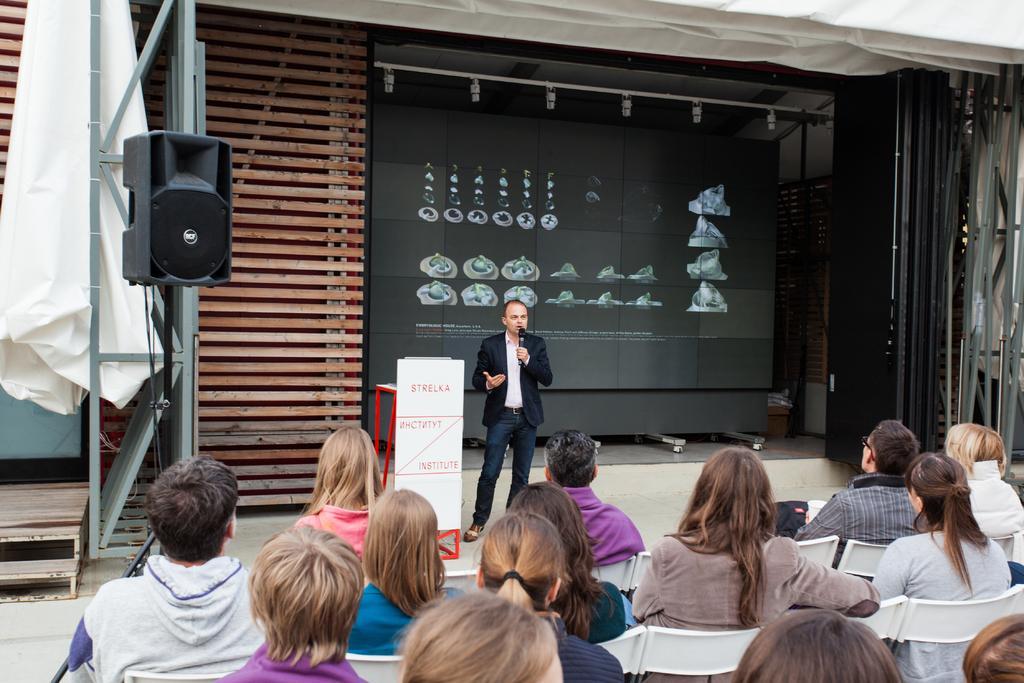How would you summarize this image in a sentence or two? In this picture there is a man who is holding a mic. He is standing near to the banners. In the back I can see the black color board which is placed near to the wall. On the left there is a speaker. At the bottom I can see many peoples who are sitting on the chair. 